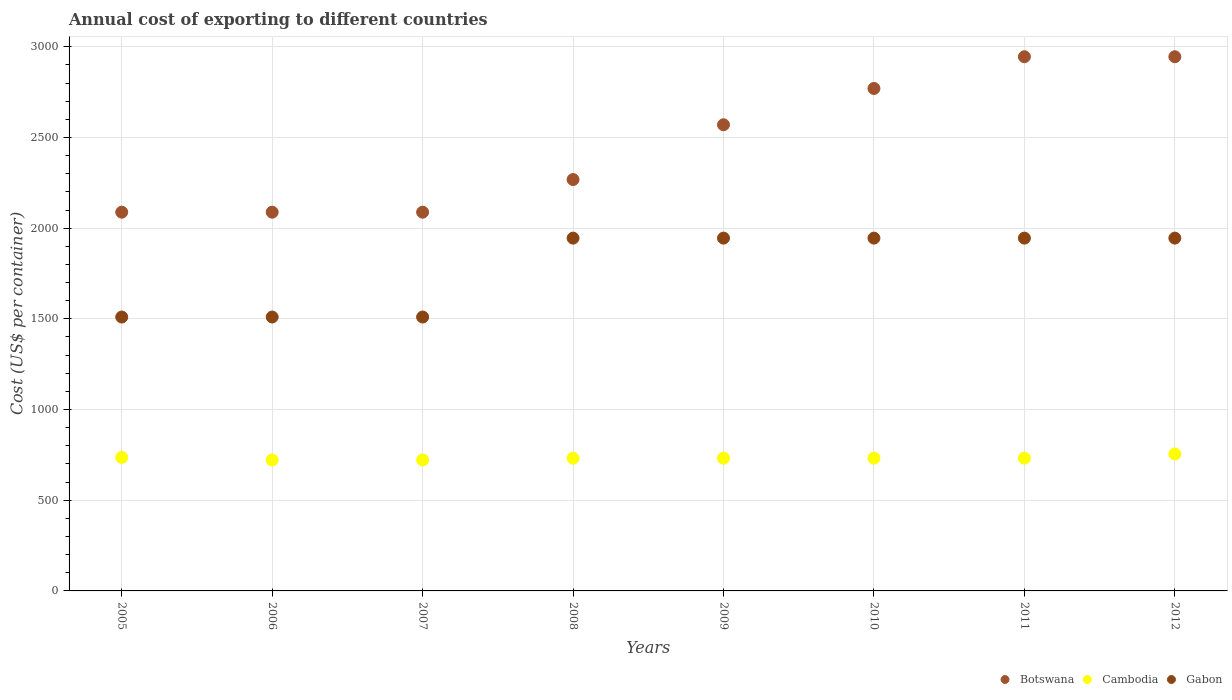How many different coloured dotlines are there?
Provide a short and direct response. 3. Is the number of dotlines equal to the number of legend labels?
Keep it short and to the point. Yes. What is the total annual cost of exporting in Botswana in 2012?
Offer a terse response. 2945. Across all years, what is the maximum total annual cost of exporting in Gabon?
Offer a very short reply. 1945. Across all years, what is the minimum total annual cost of exporting in Gabon?
Ensure brevity in your answer.  1510. What is the total total annual cost of exporting in Cambodia in the graph?
Give a very brief answer. 5863. What is the difference between the total annual cost of exporting in Cambodia in 2008 and that in 2009?
Make the answer very short. 0. What is the difference between the total annual cost of exporting in Botswana in 2006 and the total annual cost of exporting in Cambodia in 2009?
Make the answer very short. 1356. What is the average total annual cost of exporting in Botswana per year?
Provide a succinct answer. 2470.25. In the year 2007, what is the difference between the total annual cost of exporting in Gabon and total annual cost of exporting in Botswana?
Your response must be concise. -578. What is the ratio of the total annual cost of exporting in Cambodia in 2005 to that in 2012?
Your response must be concise. 0.97. Is the total annual cost of exporting in Botswana in 2009 less than that in 2010?
Your response must be concise. Yes. Is the difference between the total annual cost of exporting in Gabon in 2005 and 2006 greater than the difference between the total annual cost of exporting in Botswana in 2005 and 2006?
Provide a short and direct response. No. What is the difference between the highest and the lowest total annual cost of exporting in Botswana?
Make the answer very short. 857. In how many years, is the total annual cost of exporting in Cambodia greater than the average total annual cost of exporting in Cambodia taken over all years?
Keep it short and to the point. 2. Is the sum of the total annual cost of exporting in Cambodia in 2008 and 2009 greater than the maximum total annual cost of exporting in Botswana across all years?
Your answer should be compact. No. Is it the case that in every year, the sum of the total annual cost of exporting in Cambodia and total annual cost of exporting in Botswana  is greater than the total annual cost of exporting in Gabon?
Offer a very short reply. Yes. Does the total annual cost of exporting in Gabon monotonically increase over the years?
Offer a very short reply. No. How many dotlines are there?
Your response must be concise. 3. How many years are there in the graph?
Make the answer very short. 8. Are the values on the major ticks of Y-axis written in scientific E-notation?
Provide a short and direct response. No. Does the graph contain grids?
Make the answer very short. Yes. Where does the legend appear in the graph?
Give a very brief answer. Bottom right. How many legend labels are there?
Your response must be concise. 3. What is the title of the graph?
Ensure brevity in your answer.  Annual cost of exporting to different countries. Does "Cyprus" appear as one of the legend labels in the graph?
Your answer should be very brief. No. What is the label or title of the Y-axis?
Ensure brevity in your answer.  Cost (US$ per container). What is the Cost (US$ per container) in Botswana in 2005?
Provide a short and direct response. 2088. What is the Cost (US$ per container) in Cambodia in 2005?
Your response must be concise. 736. What is the Cost (US$ per container) in Gabon in 2005?
Keep it short and to the point. 1510. What is the Cost (US$ per container) of Botswana in 2006?
Ensure brevity in your answer.  2088. What is the Cost (US$ per container) in Cambodia in 2006?
Your answer should be compact. 722. What is the Cost (US$ per container) of Gabon in 2006?
Keep it short and to the point. 1510. What is the Cost (US$ per container) in Botswana in 2007?
Provide a succinct answer. 2088. What is the Cost (US$ per container) of Cambodia in 2007?
Provide a succinct answer. 722. What is the Cost (US$ per container) in Gabon in 2007?
Your answer should be compact. 1510. What is the Cost (US$ per container) in Botswana in 2008?
Ensure brevity in your answer.  2268. What is the Cost (US$ per container) of Cambodia in 2008?
Keep it short and to the point. 732. What is the Cost (US$ per container) in Gabon in 2008?
Make the answer very short. 1945. What is the Cost (US$ per container) in Botswana in 2009?
Offer a terse response. 2570. What is the Cost (US$ per container) of Cambodia in 2009?
Provide a short and direct response. 732. What is the Cost (US$ per container) of Gabon in 2009?
Make the answer very short. 1945. What is the Cost (US$ per container) in Botswana in 2010?
Your answer should be very brief. 2770. What is the Cost (US$ per container) of Cambodia in 2010?
Your answer should be compact. 732. What is the Cost (US$ per container) of Gabon in 2010?
Offer a terse response. 1945. What is the Cost (US$ per container) in Botswana in 2011?
Provide a short and direct response. 2945. What is the Cost (US$ per container) of Cambodia in 2011?
Offer a terse response. 732. What is the Cost (US$ per container) of Gabon in 2011?
Offer a very short reply. 1945. What is the Cost (US$ per container) in Botswana in 2012?
Make the answer very short. 2945. What is the Cost (US$ per container) in Cambodia in 2012?
Offer a terse response. 755. What is the Cost (US$ per container) of Gabon in 2012?
Your answer should be compact. 1945. Across all years, what is the maximum Cost (US$ per container) in Botswana?
Make the answer very short. 2945. Across all years, what is the maximum Cost (US$ per container) in Cambodia?
Offer a very short reply. 755. Across all years, what is the maximum Cost (US$ per container) in Gabon?
Your answer should be very brief. 1945. Across all years, what is the minimum Cost (US$ per container) of Botswana?
Provide a short and direct response. 2088. Across all years, what is the minimum Cost (US$ per container) in Cambodia?
Provide a succinct answer. 722. Across all years, what is the minimum Cost (US$ per container) of Gabon?
Give a very brief answer. 1510. What is the total Cost (US$ per container) of Botswana in the graph?
Your answer should be very brief. 1.98e+04. What is the total Cost (US$ per container) in Cambodia in the graph?
Provide a short and direct response. 5863. What is the total Cost (US$ per container) in Gabon in the graph?
Provide a succinct answer. 1.43e+04. What is the difference between the Cost (US$ per container) of Cambodia in 2005 and that in 2006?
Your response must be concise. 14. What is the difference between the Cost (US$ per container) in Botswana in 2005 and that in 2007?
Make the answer very short. 0. What is the difference between the Cost (US$ per container) in Cambodia in 2005 and that in 2007?
Provide a succinct answer. 14. What is the difference between the Cost (US$ per container) of Botswana in 2005 and that in 2008?
Provide a short and direct response. -180. What is the difference between the Cost (US$ per container) in Gabon in 2005 and that in 2008?
Offer a very short reply. -435. What is the difference between the Cost (US$ per container) in Botswana in 2005 and that in 2009?
Your answer should be very brief. -482. What is the difference between the Cost (US$ per container) in Cambodia in 2005 and that in 2009?
Make the answer very short. 4. What is the difference between the Cost (US$ per container) in Gabon in 2005 and that in 2009?
Ensure brevity in your answer.  -435. What is the difference between the Cost (US$ per container) of Botswana in 2005 and that in 2010?
Provide a succinct answer. -682. What is the difference between the Cost (US$ per container) of Cambodia in 2005 and that in 2010?
Ensure brevity in your answer.  4. What is the difference between the Cost (US$ per container) in Gabon in 2005 and that in 2010?
Make the answer very short. -435. What is the difference between the Cost (US$ per container) in Botswana in 2005 and that in 2011?
Offer a terse response. -857. What is the difference between the Cost (US$ per container) in Gabon in 2005 and that in 2011?
Keep it short and to the point. -435. What is the difference between the Cost (US$ per container) in Botswana in 2005 and that in 2012?
Offer a very short reply. -857. What is the difference between the Cost (US$ per container) in Gabon in 2005 and that in 2012?
Give a very brief answer. -435. What is the difference between the Cost (US$ per container) in Cambodia in 2006 and that in 2007?
Give a very brief answer. 0. What is the difference between the Cost (US$ per container) of Gabon in 2006 and that in 2007?
Keep it short and to the point. 0. What is the difference between the Cost (US$ per container) in Botswana in 2006 and that in 2008?
Provide a succinct answer. -180. What is the difference between the Cost (US$ per container) in Cambodia in 2006 and that in 2008?
Offer a terse response. -10. What is the difference between the Cost (US$ per container) in Gabon in 2006 and that in 2008?
Your answer should be very brief. -435. What is the difference between the Cost (US$ per container) of Botswana in 2006 and that in 2009?
Keep it short and to the point. -482. What is the difference between the Cost (US$ per container) of Gabon in 2006 and that in 2009?
Offer a very short reply. -435. What is the difference between the Cost (US$ per container) of Botswana in 2006 and that in 2010?
Keep it short and to the point. -682. What is the difference between the Cost (US$ per container) of Cambodia in 2006 and that in 2010?
Your response must be concise. -10. What is the difference between the Cost (US$ per container) of Gabon in 2006 and that in 2010?
Provide a short and direct response. -435. What is the difference between the Cost (US$ per container) in Botswana in 2006 and that in 2011?
Your answer should be very brief. -857. What is the difference between the Cost (US$ per container) in Gabon in 2006 and that in 2011?
Provide a succinct answer. -435. What is the difference between the Cost (US$ per container) of Botswana in 2006 and that in 2012?
Offer a terse response. -857. What is the difference between the Cost (US$ per container) of Cambodia in 2006 and that in 2012?
Your answer should be very brief. -33. What is the difference between the Cost (US$ per container) in Gabon in 2006 and that in 2012?
Make the answer very short. -435. What is the difference between the Cost (US$ per container) of Botswana in 2007 and that in 2008?
Make the answer very short. -180. What is the difference between the Cost (US$ per container) of Gabon in 2007 and that in 2008?
Provide a short and direct response. -435. What is the difference between the Cost (US$ per container) in Botswana in 2007 and that in 2009?
Make the answer very short. -482. What is the difference between the Cost (US$ per container) in Cambodia in 2007 and that in 2009?
Keep it short and to the point. -10. What is the difference between the Cost (US$ per container) in Gabon in 2007 and that in 2009?
Provide a short and direct response. -435. What is the difference between the Cost (US$ per container) in Botswana in 2007 and that in 2010?
Provide a succinct answer. -682. What is the difference between the Cost (US$ per container) in Cambodia in 2007 and that in 2010?
Keep it short and to the point. -10. What is the difference between the Cost (US$ per container) of Gabon in 2007 and that in 2010?
Give a very brief answer. -435. What is the difference between the Cost (US$ per container) of Botswana in 2007 and that in 2011?
Give a very brief answer. -857. What is the difference between the Cost (US$ per container) of Cambodia in 2007 and that in 2011?
Offer a very short reply. -10. What is the difference between the Cost (US$ per container) in Gabon in 2007 and that in 2011?
Keep it short and to the point. -435. What is the difference between the Cost (US$ per container) in Botswana in 2007 and that in 2012?
Your answer should be very brief. -857. What is the difference between the Cost (US$ per container) of Cambodia in 2007 and that in 2012?
Your response must be concise. -33. What is the difference between the Cost (US$ per container) in Gabon in 2007 and that in 2012?
Your answer should be very brief. -435. What is the difference between the Cost (US$ per container) of Botswana in 2008 and that in 2009?
Offer a terse response. -302. What is the difference between the Cost (US$ per container) of Gabon in 2008 and that in 2009?
Make the answer very short. 0. What is the difference between the Cost (US$ per container) of Botswana in 2008 and that in 2010?
Ensure brevity in your answer.  -502. What is the difference between the Cost (US$ per container) of Cambodia in 2008 and that in 2010?
Your answer should be compact. 0. What is the difference between the Cost (US$ per container) of Gabon in 2008 and that in 2010?
Make the answer very short. 0. What is the difference between the Cost (US$ per container) of Botswana in 2008 and that in 2011?
Your response must be concise. -677. What is the difference between the Cost (US$ per container) in Cambodia in 2008 and that in 2011?
Provide a succinct answer. 0. What is the difference between the Cost (US$ per container) in Botswana in 2008 and that in 2012?
Make the answer very short. -677. What is the difference between the Cost (US$ per container) of Cambodia in 2008 and that in 2012?
Ensure brevity in your answer.  -23. What is the difference between the Cost (US$ per container) of Gabon in 2008 and that in 2012?
Offer a terse response. 0. What is the difference between the Cost (US$ per container) in Botswana in 2009 and that in 2010?
Offer a terse response. -200. What is the difference between the Cost (US$ per container) of Botswana in 2009 and that in 2011?
Provide a short and direct response. -375. What is the difference between the Cost (US$ per container) of Gabon in 2009 and that in 2011?
Your answer should be compact. 0. What is the difference between the Cost (US$ per container) of Botswana in 2009 and that in 2012?
Provide a succinct answer. -375. What is the difference between the Cost (US$ per container) in Gabon in 2009 and that in 2012?
Offer a very short reply. 0. What is the difference between the Cost (US$ per container) of Botswana in 2010 and that in 2011?
Your answer should be very brief. -175. What is the difference between the Cost (US$ per container) of Gabon in 2010 and that in 2011?
Your answer should be compact. 0. What is the difference between the Cost (US$ per container) in Botswana in 2010 and that in 2012?
Ensure brevity in your answer.  -175. What is the difference between the Cost (US$ per container) in Cambodia in 2010 and that in 2012?
Offer a terse response. -23. What is the difference between the Cost (US$ per container) in Botswana in 2011 and that in 2012?
Keep it short and to the point. 0. What is the difference between the Cost (US$ per container) of Cambodia in 2011 and that in 2012?
Make the answer very short. -23. What is the difference between the Cost (US$ per container) of Gabon in 2011 and that in 2012?
Offer a very short reply. 0. What is the difference between the Cost (US$ per container) in Botswana in 2005 and the Cost (US$ per container) in Cambodia in 2006?
Offer a terse response. 1366. What is the difference between the Cost (US$ per container) in Botswana in 2005 and the Cost (US$ per container) in Gabon in 2006?
Offer a very short reply. 578. What is the difference between the Cost (US$ per container) of Cambodia in 2005 and the Cost (US$ per container) of Gabon in 2006?
Your answer should be very brief. -774. What is the difference between the Cost (US$ per container) of Botswana in 2005 and the Cost (US$ per container) of Cambodia in 2007?
Offer a very short reply. 1366. What is the difference between the Cost (US$ per container) in Botswana in 2005 and the Cost (US$ per container) in Gabon in 2007?
Offer a terse response. 578. What is the difference between the Cost (US$ per container) in Cambodia in 2005 and the Cost (US$ per container) in Gabon in 2007?
Offer a terse response. -774. What is the difference between the Cost (US$ per container) of Botswana in 2005 and the Cost (US$ per container) of Cambodia in 2008?
Offer a very short reply. 1356. What is the difference between the Cost (US$ per container) in Botswana in 2005 and the Cost (US$ per container) in Gabon in 2008?
Keep it short and to the point. 143. What is the difference between the Cost (US$ per container) of Cambodia in 2005 and the Cost (US$ per container) of Gabon in 2008?
Make the answer very short. -1209. What is the difference between the Cost (US$ per container) in Botswana in 2005 and the Cost (US$ per container) in Cambodia in 2009?
Make the answer very short. 1356. What is the difference between the Cost (US$ per container) in Botswana in 2005 and the Cost (US$ per container) in Gabon in 2009?
Offer a very short reply. 143. What is the difference between the Cost (US$ per container) of Cambodia in 2005 and the Cost (US$ per container) of Gabon in 2009?
Your answer should be very brief. -1209. What is the difference between the Cost (US$ per container) of Botswana in 2005 and the Cost (US$ per container) of Cambodia in 2010?
Ensure brevity in your answer.  1356. What is the difference between the Cost (US$ per container) of Botswana in 2005 and the Cost (US$ per container) of Gabon in 2010?
Provide a short and direct response. 143. What is the difference between the Cost (US$ per container) in Cambodia in 2005 and the Cost (US$ per container) in Gabon in 2010?
Your answer should be compact. -1209. What is the difference between the Cost (US$ per container) of Botswana in 2005 and the Cost (US$ per container) of Cambodia in 2011?
Make the answer very short. 1356. What is the difference between the Cost (US$ per container) in Botswana in 2005 and the Cost (US$ per container) in Gabon in 2011?
Keep it short and to the point. 143. What is the difference between the Cost (US$ per container) of Cambodia in 2005 and the Cost (US$ per container) of Gabon in 2011?
Your response must be concise. -1209. What is the difference between the Cost (US$ per container) of Botswana in 2005 and the Cost (US$ per container) of Cambodia in 2012?
Ensure brevity in your answer.  1333. What is the difference between the Cost (US$ per container) in Botswana in 2005 and the Cost (US$ per container) in Gabon in 2012?
Your answer should be very brief. 143. What is the difference between the Cost (US$ per container) in Cambodia in 2005 and the Cost (US$ per container) in Gabon in 2012?
Offer a very short reply. -1209. What is the difference between the Cost (US$ per container) of Botswana in 2006 and the Cost (US$ per container) of Cambodia in 2007?
Provide a succinct answer. 1366. What is the difference between the Cost (US$ per container) of Botswana in 2006 and the Cost (US$ per container) of Gabon in 2007?
Offer a very short reply. 578. What is the difference between the Cost (US$ per container) of Cambodia in 2006 and the Cost (US$ per container) of Gabon in 2007?
Keep it short and to the point. -788. What is the difference between the Cost (US$ per container) in Botswana in 2006 and the Cost (US$ per container) in Cambodia in 2008?
Ensure brevity in your answer.  1356. What is the difference between the Cost (US$ per container) of Botswana in 2006 and the Cost (US$ per container) of Gabon in 2008?
Your response must be concise. 143. What is the difference between the Cost (US$ per container) of Cambodia in 2006 and the Cost (US$ per container) of Gabon in 2008?
Provide a succinct answer. -1223. What is the difference between the Cost (US$ per container) in Botswana in 2006 and the Cost (US$ per container) in Cambodia in 2009?
Provide a short and direct response. 1356. What is the difference between the Cost (US$ per container) of Botswana in 2006 and the Cost (US$ per container) of Gabon in 2009?
Ensure brevity in your answer.  143. What is the difference between the Cost (US$ per container) in Cambodia in 2006 and the Cost (US$ per container) in Gabon in 2009?
Your response must be concise. -1223. What is the difference between the Cost (US$ per container) in Botswana in 2006 and the Cost (US$ per container) in Cambodia in 2010?
Offer a very short reply. 1356. What is the difference between the Cost (US$ per container) of Botswana in 2006 and the Cost (US$ per container) of Gabon in 2010?
Provide a succinct answer. 143. What is the difference between the Cost (US$ per container) of Cambodia in 2006 and the Cost (US$ per container) of Gabon in 2010?
Your answer should be very brief. -1223. What is the difference between the Cost (US$ per container) in Botswana in 2006 and the Cost (US$ per container) in Cambodia in 2011?
Your response must be concise. 1356. What is the difference between the Cost (US$ per container) of Botswana in 2006 and the Cost (US$ per container) of Gabon in 2011?
Make the answer very short. 143. What is the difference between the Cost (US$ per container) in Cambodia in 2006 and the Cost (US$ per container) in Gabon in 2011?
Your answer should be compact. -1223. What is the difference between the Cost (US$ per container) in Botswana in 2006 and the Cost (US$ per container) in Cambodia in 2012?
Ensure brevity in your answer.  1333. What is the difference between the Cost (US$ per container) in Botswana in 2006 and the Cost (US$ per container) in Gabon in 2012?
Keep it short and to the point. 143. What is the difference between the Cost (US$ per container) of Cambodia in 2006 and the Cost (US$ per container) of Gabon in 2012?
Give a very brief answer. -1223. What is the difference between the Cost (US$ per container) of Botswana in 2007 and the Cost (US$ per container) of Cambodia in 2008?
Your response must be concise. 1356. What is the difference between the Cost (US$ per container) of Botswana in 2007 and the Cost (US$ per container) of Gabon in 2008?
Provide a succinct answer. 143. What is the difference between the Cost (US$ per container) in Cambodia in 2007 and the Cost (US$ per container) in Gabon in 2008?
Your answer should be very brief. -1223. What is the difference between the Cost (US$ per container) in Botswana in 2007 and the Cost (US$ per container) in Cambodia in 2009?
Give a very brief answer. 1356. What is the difference between the Cost (US$ per container) of Botswana in 2007 and the Cost (US$ per container) of Gabon in 2009?
Your response must be concise. 143. What is the difference between the Cost (US$ per container) of Cambodia in 2007 and the Cost (US$ per container) of Gabon in 2009?
Give a very brief answer. -1223. What is the difference between the Cost (US$ per container) of Botswana in 2007 and the Cost (US$ per container) of Cambodia in 2010?
Your answer should be compact. 1356. What is the difference between the Cost (US$ per container) in Botswana in 2007 and the Cost (US$ per container) in Gabon in 2010?
Make the answer very short. 143. What is the difference between the Cost (US$ per container) of Cambodia in 2007 and the Cost (US$ per container) of Gabon in 2010?
Your answer should be compact. -1223. What is the difference between the Cost (US$ per container) of Botswana in 2007 and the Cost (US$ per container) of Cambodia in 2011?
Give a very brief answer. 1356. What is the difference between the Cost (US$ per container) in Botswana in 2007 and the Cost (US$ per container) in Gabon in 2011?
Your response must be concise. 143. What is the difference between the Cost (US$ per container) of Cambodia in 2007 and the Cost (US$ per container) of Gabon in 2011?
Your answer should be very brief. -1223. What is the difference between the Cost (US$ per container) in Botswana in 2007 and the Cost (US$ per container) in Cambodia in 2012?
Ensure brevity in your answer.  1333. What is the difference between the Cost (US$ per container) of Botswana in 2007 and the Cost (US$ per container) of Gabon in 2012?
Provide a succinct answer. 143. What is the difference between the Cost (US$ per container) of Cambodia in 2007 and the Cost (US$ per container) of Gabon in 2012?
Your response must be concise. -1223. What is the difference between the Cost (US$ per container) of Botswana in 2008 and the Cost (US$ per container) of Cambodia in 2009?
Offer a very short reply. 1536. What is the difference between the Cost (US$ per container) in Botswana in 2008 and the Cost (US$ per container) in Gabon in 2009?
Give a very brief answer. 323. What is the difference between the Cost (US$ per container) of Cambodia in 2008 and the Cost (US$ per container) of Gabon in 2009?
Provide a succinct answer. -1213. What is the difference between the Cost (US$ per container) of Botswana in 2008 and the Cost (US$ per container) of Cambodia in 2010?
Keep it short and to the point. 1536. What is the difference between the Cost (US$ per container) in Botswana in 2008 and the Cost (US$ per container) in Gabon in 2010?
Your answer should be very brief. 323. What is the difference between the Cost (US$ per container) in Cambodia in 2008 and the Cost (US$ per container) in Gabon in 2010?
Make the answer very short. -1213. What is the difference between the Cost (US$ per container) in Botswana in 2008 and the Cost (US$ per container) in Cambodia in 2011?
Your response must be concise. 1536. What is the difference between the Cost (US$ per container) in Botswana in 2008 and the Cost (US$ per container) in Gabon in 2011?
Provide a short and direct response. 323. What is the difference between the Cost (US$ per container) of Cambodia in 2008 and the Cost (US$ per container) of Gabon in 2011?
Keep it short and to the point. -1213. What is the difference between the Cost (US$ per container) in Botswana in 2008 and the Cost (US$ per container) in Cambodia in 2012?
Your response must be concise. 1513. What is the difference between the Cost (US$ per container) in Botswana in 2008 and the Cost (US$ per container) in Gabon in 2012?
Your response must be concise. 323. What is the difference between the Cost (US$ per container) in Cambodia in 2008 and the Cost (US$ per container) in Gabon in 2012?
Make the answer very short. -1213. What is the difference between the Cost (US$ per container) of Botswana in 2009 and the Cost (US$ per container) of Cambodia in 2010?
Make the answer very short. 1838. What is the difference between the Cost (US$ per container) in Botswana in 2009 and the Cost (US$ per container) in Gabon in 2010?
Your answer should be compact. 625. What is the difference between the Cost (US$ per container) in Cambodia in 2009 and the Cost (US$ per container) in Gabon in 2010?
Give a very brief answer. -1213. What is the difference between the Cost (US$ per container) in Botswana in 2009 and the Cost (US$ per container) in Cambodia in 2011?
Your answer should be very brief. 1838. What is the difference between the Cost (US$ per container) in Botswana in 2009 and the Cost (US$ per container) in Gabon in 2011?
Your answer should be very brief. 625. What is the difference between the Cost (US$ per container) of Cambodia in 2009 and the Cost (US$ per container) of Gabon in 2011?
Keep it short and to the point. -1213. What is the difference between the Cost (US$ per container) in Botswana in 2009 and the Cost (US$ per container) in Cambodia in 2012?
Ensure brevity in your answer.  1815. What is the difference between the Cost (US$ per container) of Botswana in 2009 and the Cost (US$ per container) of Gabon in 2012?
Offer a terse response. 625. What is the difference between the Cost (US$ per container) of Cambodia in 2009 and the Cost (US$ per container) of Gabon in 2012?
Keep it short and to the point. -1213. What is the difference between the Cost (US$ per container) of Botswana in 2010 and the Cost (US$ per container) of Cambodia in 2011?
Ensure brevity in your answer.  2038. What is the difference between the Cost (US$ per container) of Botswana in 2010 and the Cost (US$ per container) of Gabon in 2011?
Your response must be concise. 825. What is the difference between the Cost (US$ per container) in Cambodia in 2010 and the Cost (US$ per container) in Gabon in 2011?
Make the answer very short. -1213. What is the difference between the Cost (US$ per container) in Botswana in 2010 and the Cost (US$ per container) in Cambodia in 2012?
Your answer should be compact. 2015. What is the difference between the Cost (US$ per container) of Botswana in 2010 and the Cost (US$ per container) of Gabon in 2012?
Make the answer very short. 825. What is the difference between the Cost (US$ per container) of Cambodia in 2010 and the Cost (US$ per container) of Gabon in 2012?
Offer a very short reply. -1213. What is the difference between the Cost (US$ per container) of Botswana in 2011 and the Cost (US$ per container) of Cambodia in 2012?
Your answer should be compact. 2190. What is the difference between the Cost (US$ per container) of Cambodia in 2011 and the Cost (US$ per container) of Gabon in 2012?
Ensure brevity in your answer.  -1213. What is the average Cost (US$ per container) of Botswana per year?
Ensure brevity in your answer.  2470.25. What is the average Cost (US$ per container) of Cambodia per year?
Offer a very short reply. 732.88. What is the average Cost (US$ per container) of Gabon per year?
Offer a very short reply. 1781.88. In the year 2005, what is the difference between the Cost (US$ per container) in Botswana and Cost (US$ per container) in Cambodia?
Your answer should be compact. 1352. In the year 2005, what is the difference between the Cost (US$ per container) of Botswana and Cost (US$ per container) of Gabon?
Offer a terse response. 578. In the year 2005, what is the difference between the Cost (US$ per container) in Cambodia and Cost (US$ per container) in Gabon?
Your answer should be very brief. -774. In the year 2006, what is the difference between the Cost (US$ per container) of Botswana and Cost (US$ per container) of Cambodia?
Provide a succinct answer. 1366. In the year 2006, what is the difference between the Cost (US$ per container) in Botswana and Cost (US$ per container) in Gabon?
Make the answer very short. 578. In the year 2006, what is the difference between the Cost (US$ per container) in Cambodia and Cost (US$ per container) in Gabon?
Provide a short and direct response. -788. In the year 2007, what is the difference between the Cost (US$ per container) in Botswana and Cost (US$ per container) in Cambodia?
Offer a terse response. 1366. In the year 2007, what is the difference between the Cost (US$ per container) of Botswana and Cost (US$ per container) of Gabon?
Offer a terse response. 578. In the year 2007, what is the difference between the Cost (US$ per container) of Cambodia and Cost (US$ per container) of Gabon?
Ensure brevity in your answer.  -788. In the year 2008, what is the difference between the Cost (US$ per container) in Botswana and Cost (US$ per container) in Cambodia?
Keep it short and to the point. 1536. In the year 2008, what is the difference between the Cost (US$ per container) in Botswana and Cost (US$ per container) in Gabon?
Offer a terse response. 323. In the year 2008, what is the difference between the Cost (US$ per container) of Cambodia and Cost (US$ per container) of Gabon?
Keep it short and to the point. -1213. In the year 2009, what is the difference between the Cost (US$ per container) of Botswana and Cost (US$ per container) of Cambodia?
Make the answer very short. 1838. In the year 2009, what is the difference between the Cost (US$ per container) in Botswana and Cost (US$ per container) in Gabon?
Your answer should be very brief. 625. In the year 2009, what is the difference between the Cost (US$ per container) in Cambodia and Cost (US$ per container) in Gabon?
Offer a very short reply. -1213. In the year 2010, what is the difference between the Cost (US$ per container) of Botswana and Cost (US$ per container) of Cambodia?
Offer a terse response. 2038. In the year 2010, what is the difference between the Cost (US$ per container) of Botswana and Cost (US$ per container) of Gabon?
Keep it short and to the point. 825. In the year 2010, what is the difference between the Cost (US$ per container) of Cambodia and Cost (US$ per container) of Gabon?
Provide a short and direct response. -1213. In the year 2011, what is the difference between the Cost (US$ per container) of Botswana and Cost (US$ per container) of Cambodia?
Give a very brief answer. 2213. In the year 2011, what is the difference between the Cost (US$ per container) in Botswana and Cost (US$ per container) in Gabon?
Offer a very short reply. 1000. In the year 2011, what is the difference between the Cost (US$ per container) in Cambodia and Cost (US$ per container) in Gabon?
Provide a short and direct response. -1213. In the year 2012, what is the difference between the Cost (US$ per container) in Botswana and Cost (US$ per container) in Cambodia?
Offer a terse response. 2190. In the year 2012, what is the difference between the Cost (US$ per container) in Cambodia and Cost (US$ per container) in Gabon?
Keep it short and to the point. -1190. What is the ratio of the Cost (US$ per container) in Cambodia in 2005 to that in 2006?
Make the answer very short. 1.02. What is the ratio of the Cost (US$ per container) in Botswana in 2005 to that in 2007?
Provide a short and direct response. 1. What is the ratio of the Cost (US$ per container) in Cambodia in 2005 to that in 2007?
Your answer should be compact. 1.02. What is the ratio of the Cost (US$ per container) of Gabon in 2005 to that in 2007?
Provide a succinct answer. 1. What is the ratio of the Cost (US$ per container) in Botswana in 2005 to that in 2008?
Offer a very short reply. 0.92. What is the ratio of the Cost (US$ per container) in Gabon in 2005 to that in 2008?
Give a very brief answer. 0.78. What is the ratio of the Cost (US$ per container) of Botswana in 2005 to that in 2009?
Offer a terse response. 0.81. What is the ratio of the Cost (US$ per container) of Cambodia in 2005 to that in 2009?
Offer a terse response. 1.01. What is the ratio of the Cost (US$ per container) of Gabon in 2005 to that in 2009?
Make the answer very short. 0.78. What is the ratio of the Cost (US$ per container) of Botswana in 2005 to that in 2010?
Your answer should be compact. 0.75. What is the ratio of the Cost (US$ per container) in Gabon in 2005 to that in 2010?
Provide a succinct answer. 0.78. What is the ratio of the Cost (US$ per container) of Botswana in 2005 to that in 2011?
Provide a short and direct response. 0.71. What is the ratio of the Cost (US$ per container) in Cambodia in 2005 to that in 2011?
Provide a short and direct response. 1.01. What is the ratio of the Cost (US$ per container) of Gabon in 2005 to that in 2011?
Provide a succinct answer. 0.78. What is the ratio of the Cost (US$ per container) in Botswana in 2005 to that in 2012?
Your answer should be compact. 0.71. What is the ratio of the Cost (US$ per container) of Cambodia in 2005 to that in 2012?
Ensure brevity in your answer.  0.97. What is the ratio of the Cost (US$ per container) of Gabon in 2005 to that in 2012?
Offer a terse response. 0.78. What is the ratio of the Cost (US$ per container) of Cambodia in 2006 to that in 2007?
Provide a succinct answer. 1. What is the ratio of the Cost (US$ per container) of Botswana in 2006 to that in 2008?
Provide a succinct answer. 0.92. What is the ratio of the Cost (US$ per container) of Cambodia in 2006 to that in 2008?
Ensure brevity in your answer.  0.99. What is the ratio of the Cost (US$ per container) in Gabon in 2006 to that in 2008?
Ensure brevity in your answer.  0.78. What is the ratio of the Cost (US$ per container) in Botswana in 2006 to that in 2009?
Your response must be concise. 0.81. What is the ratio of the Cost (US$ per container) in Cambodia in 2006 to that in 2009?
Offer a terse response. 0.99. What is the ratio of the Cost (US$ per container) of Gabon in 2006 to that in 2009?
Keep it short and to the point. 0.78. What is the ratio of the Cost (US$ per container) of Botswana in 2006 to that in 2010?
Offer a terse response. 0.75. What is the ratio of the Cost (US$ per container) of Cambodia in 2006 to that in 2010?
Your response must be concise. 0.99. What is the ratio of the Cost (US$ per container) in Gabon in 2006 to that in 2010?
Keep it short and to the point. 0.78. What is the ratio of the Cost (US$ per container) of Botswana in 2006 to that in 2011?
Your answer should be compact. 0.71. What is the ratio of the Cost (US$ per container) in Cambodia in 2006 to that in 2011?
Your answer should be compact. 0.99. What is the ratio of the Cost (US$ per container) in Gabon in 2006 to that in 2011?
Your response must be concise. 0.78. What is the ratio of the Cost (US$ per container) of Botswana in 2006 to that in 2012?
Offer a terse response. 0.71. What is the ratio of the Cost (US$ per container) in Cambodia in 2006 to that in 2012?
Your response must be concise. 0.96. What is the ratio of the Cost (US$ per container) of Gabon in 2006 to that in 2012?
Provide a succinct answer. 0.78. What is the ratio of the Cost (US$ per container) in Botswana in 2007 to that in 2008?
Provide a short and direct response. 0.92. What is the ratio of the Cost (US$ per container) in Cambodia in 2007 to that in 2008?
Make the answer very short. 0.99. What is the ratio of the Cost (US$ per container) of Gabon in 2007 to that in 2008?
Provide a short and direct response. 0.78. What is the ratio of the Cost (US$ per container) of Botswana in 2007 to that in 2009?
Your answer should be very brief. 0.81. What is the ratio of the Cost (US$ per container) in Cambodia in 2007 to that in 2009?
Offer a very short reply. 0.99. What is the ratio of the Cost (US$ per container) in Gabon in 2007 to that in 2009?
Your answer should be compact. 0.78. What is the ratio of the Cost (US$ per container) in Botswana in 2007 to that in 2010?
Offer a terse response. 0.75. What is the ratio of the Cost (US$ per container) of Cambodia in 2007 to that in 2010?
Ensure brevity in your answer.  0.99. What is the ratio of the Cost (US$ per container) of Gabon in 2007 to that in 2010?
Provide a succinct answer. 0.78. What is the ratio of the Cost (US$ per container) in Botswana in 2007 to that in 2011?
Offer a terse response. 0.71. What is the ratio of the Cost (US$ per container) of Cambodia in 2007 to that in 2011?
Provide a succinct answer. 0.99. What is the ratio of the Cost (US$ per container) in Gabon in 2007 to that in 2011?
Your answer should be very brief. 0.78. What is the ratio of the Cost (US$ per container) of Botswana in 2007 to that in 2012?
Your answer should be very brief. 0.71. What is the ratio of the Cost (US$ per container) in Cambodia in 2007 to that in 2012?
Your answer should be compact. 0.96. What is the ratio of the Cost (US$ per container) in Gabon in 2007 to that in 2012?
Offer a very short reply. 0.78. What is the ratio of the Cost (US$ per container) in Botswana in 2008 to that in 2009?
Keep it short and to the point. 0.88. What is the ratio of the Cost (US$ per container) of Botswana in 2008 to that in 2010?
Ensure brevity in your answer.  0.82. What is the ratio of the Cost (US$ per container) in Cambodia in 2008 to that in 2010?
Provide a succinct answer. 1. What is the ratio of the Cost (US$ per container) in Gabon in 2008 to that in 2010?
Offer a very short reply. 1. What is the ratio of the Cost (US$ per container) of Botswana in 2008 to that in 2011?
Your answer should be compact. 0.77. What is the ratio of the Cost (US$ per container) of Botswana in 2008 to that in 2012?
Your answer should be compact. 0.77. What is the ratio of the Cost (US$ per container) in Cambodia in 2008 to that in 2012?
Ensure brevity in your answer.  0.97. What is the ratio of the Cost (US$ per container) of Botswana in 2009 to that in 2010?
Offer a terse response. 0.93. What is the ratio of the Cost (US$ per container) of Gabon in 2009 to that in 2010?
Make the answer very short. 1. What is the ratio of the Cost (US$ per container) in Botswana in 2009 to that in 2011?
Give a very brief answer. 0.87. What is the ratio of the Cost (US$ per container) of Botswana in 2009 to that in 2012?
Make the answer very short. 0.87. What is the ratio of the Cost (US$ per container) of Cambodia in 2009 to that in 2012?
Ensure brevity in your answer.  0.97. What is the ratio of the Cost (US$ per container) of Gabon in 2009 to that in 2012?
Ensure brevity in your answer.  1. What is the ratio of the Cost (US$ per container) of Botswana in 2010 to that in 2011?
Provide a short and direct response. 0.94. What is the ratio of the Cost (US$ per container) in Cambodia in 2010 to that in 2011?
Ensure brevity in your answer.  1. What is the ratio of the Cost (US$ per container) in Botswana in 2010 to that in 2012?
Keep it short and to the point. 0.94. What is the ratio of the Cost (US$ per container) in Cambodia in 2010 to that in 2012?
Ensure brevity in your answer.  0.97. What is the ratio of the Cost (US$ per container) in Gabon in 2010 to that in 2012?
Your answer should be very brief. 1. What is the ratio of the Cost (US$ per container) in Botswana in 2011 to that in 2012?
Keep it short and to the point. 1. What is the ratio of the Cost (US$ per container) in Cambodia in 2011 to that in 2012?
Your response must be concise. 0.97. What is the ratio of the Cost (US$ per container) of Gabon in 2011 to that in 2012?
Keep it short and to the point. 1. What is the difference between the highest and the second highest Cost (US$ per container) of Gabon?
Offer a very short reply. 0. What is the difference between the highest and the lowest Cost (US$ per container) in Botswana?
Your answer should be compact. 857. What is the difference between the highest and the lowest Cost (US$ per container) of Gabon?
Ensure brevity in your answer.  435. 